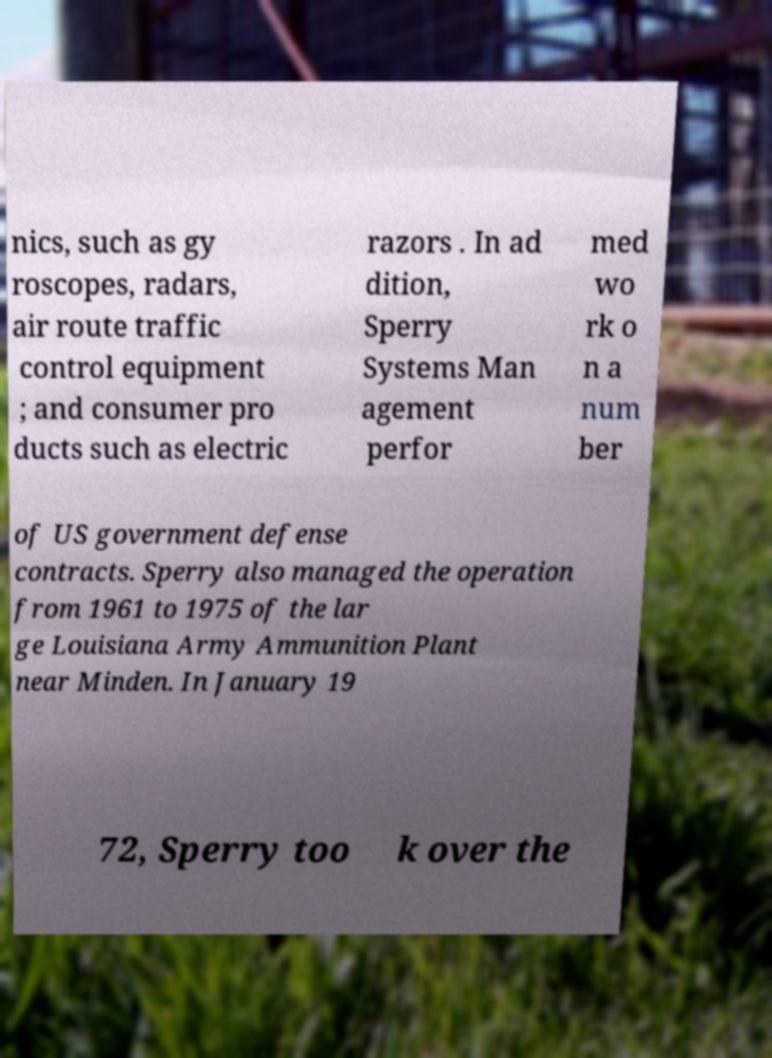Can you read and provide the text displayed in the image?This photo seems to have some interesting text. Can you extract and type it out for me? nics, such as gy roscopes, radars, air route traffic control equipment ; and consumer pro ducts such as electric razors . In ad dition, Sperry Systems Man agement perfor med wo rk o n a num ber of US government defense contracts. Sperry also managed the operation from 1961 to 1975 of the lar ge Louisiana Army Ammunition Plant near Minden. In January 19 72, Sperry too k over the 